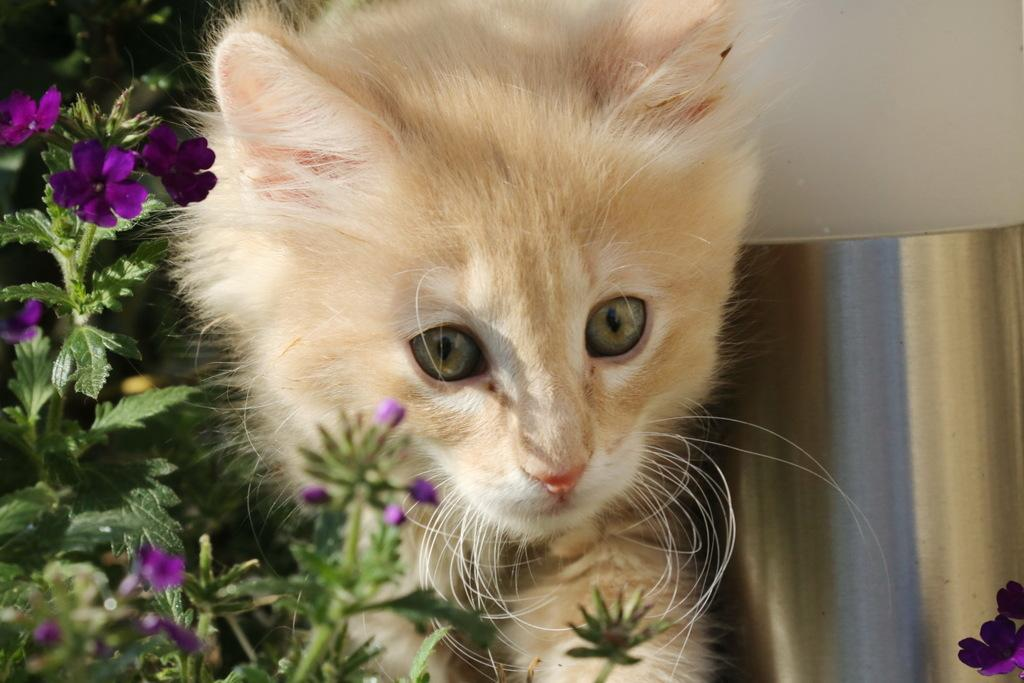What type of animal is present in the image? There is a cat in the image. What kind of vegetation can be seen in the image? There are plants with flowers in the image. What is the long, metal object in the image? There is an iron rod in the image. What type of structure is visible in the image? There is a wall in the image. How many clocks are hanging on the wall in the image? There are no clocks visible in the image; only a cat, plants with flowers, an iron rod, and a wall are present. What type of pie is being baked in the image? There is no pie present in the image. 